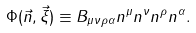Convert formula to latex. <formula><loc_0><loc_0><loc_500><loc_500>\Phi ( \vec { n } , \vec { \xi } ) \equiv B _ { \mu \nu \rho \alpha } n ^ { \mu } n ^ { \nu } n ^ { \rho } n ^ { \alpha } .</formula> 